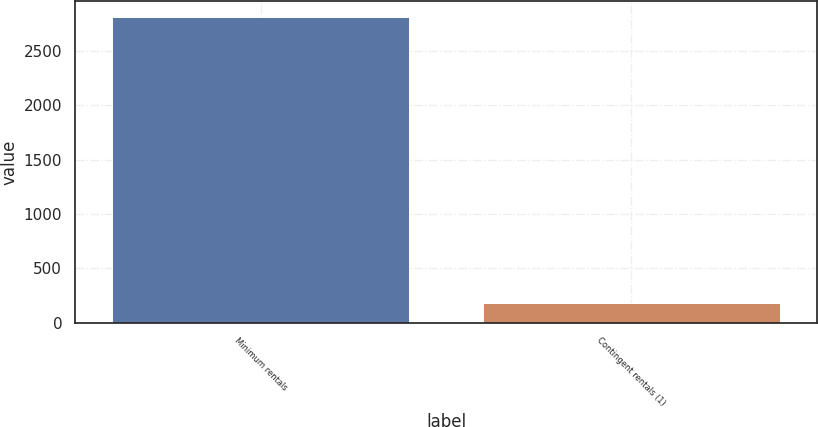Convert chart to OTSL. <chart><loc_0><loc_0><loc_500><loc_500><bar_chart><fcel>Minimum rentals<fcel>Contingent rentals (1)<nl><fcel>2814<fcel>178<nl></chart> 